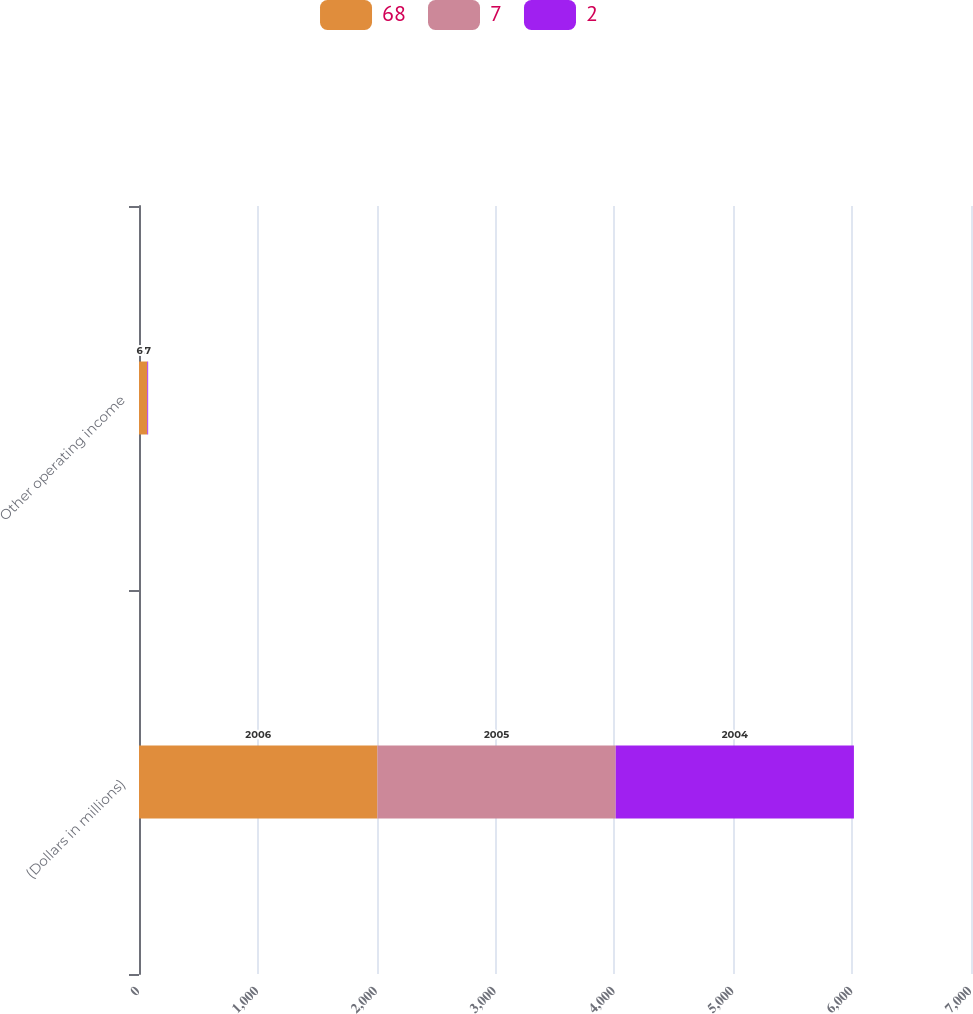Convert chart to OTSL. <chart><loc_0><loc_0><loc_500><loc_500><stacked_bar_chart><ecel><fcel>(Dollars in millions)<fcel>Other operating income<nl><fcel>68<fcel>2006<fcel>68<nl><fcel>7<fcel>2005<fcel>2<nl><fcel>2<fcel>2004<fcel>7<nl></chart> 